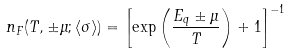Convert formula to latex. <formula><loc_0><loc_0><loc_500><loc_500>n _ { F } ( T , \pm \mu ; \langle \sigma \rangle ) = \left [ \exp \left ( \frac { E _ { q } \pm \mu } { T } \right ) + 1 \right ] ^ { - 1 }</formula> 